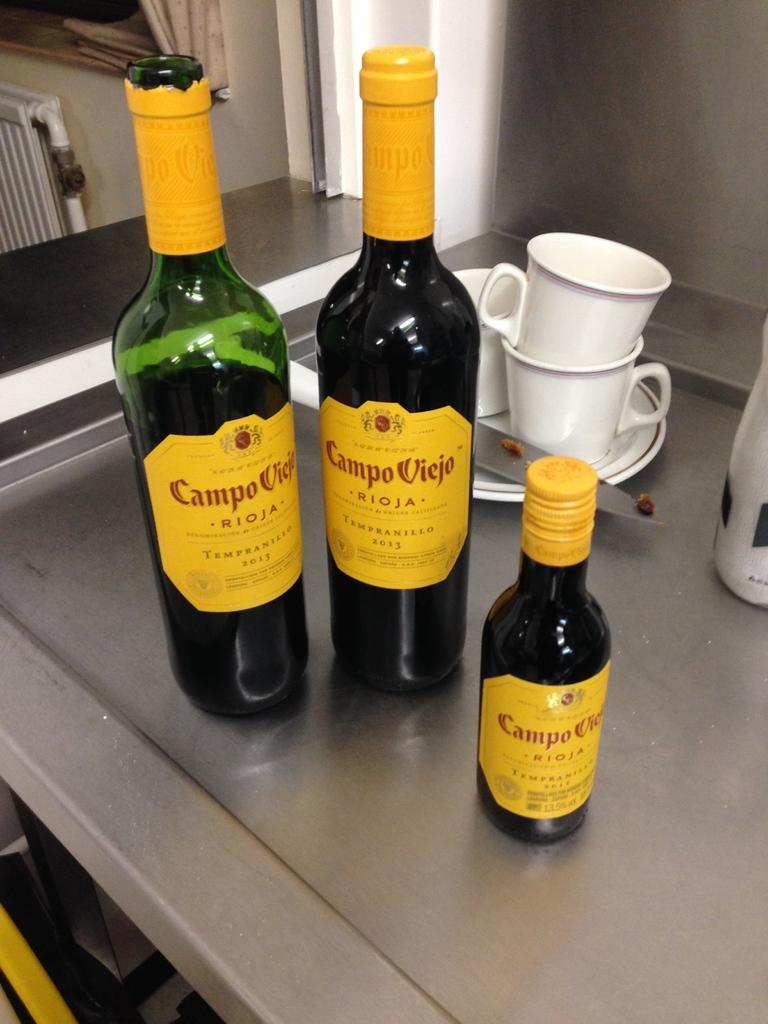What type of objects are on the table in the image? There are bottles, cups, plates, and a knife on the table in the image. Can you describe the purpose of these objects? The bottles, cups, and plates are likely used for serving and consuming food and drinks, while the knife may be used for cutting or preparing food. What does the tiger wish for in the image? There is no tiger present in the image, so it is not possible to determine what the tiger might wish for. 